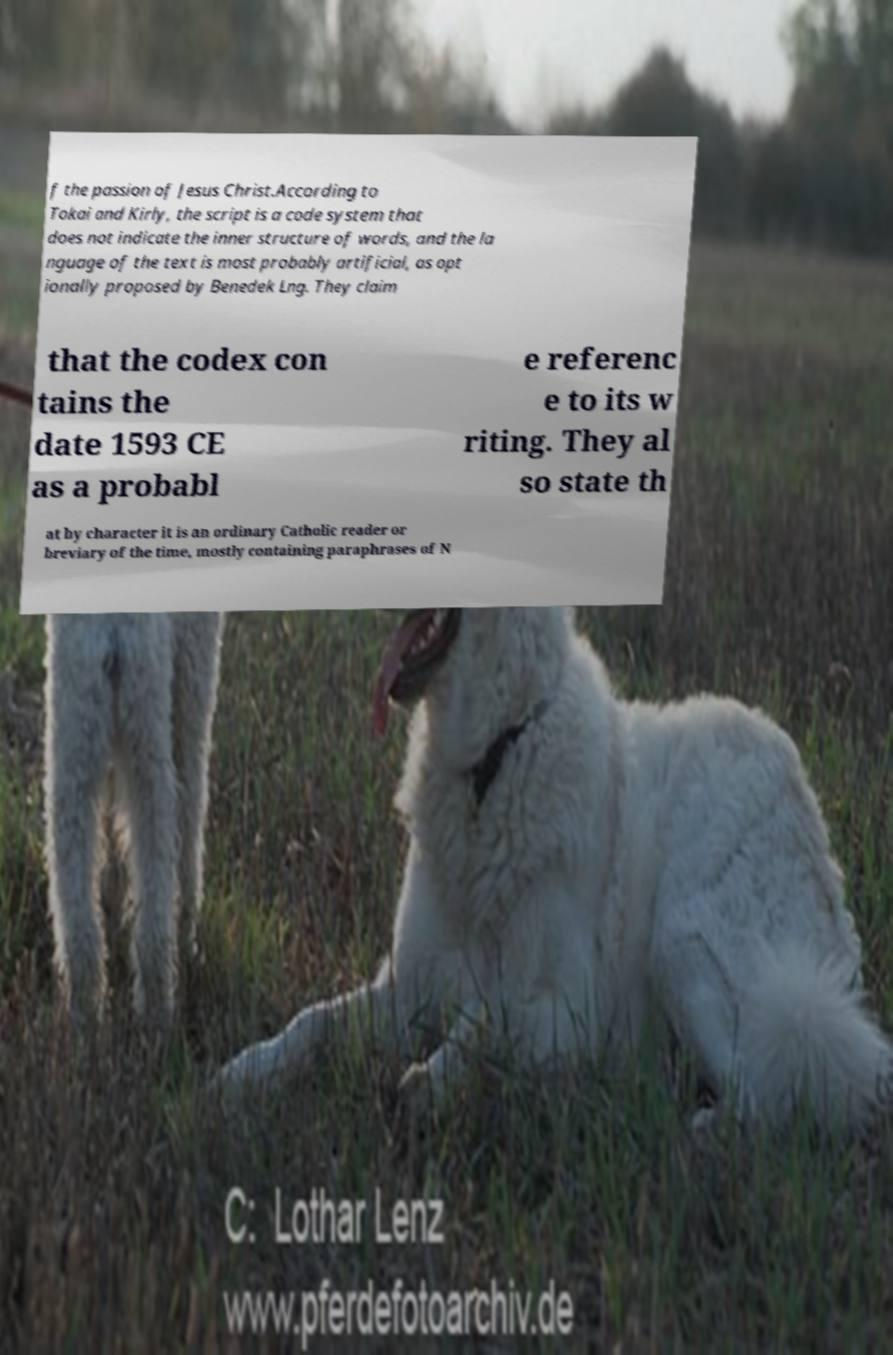Could you assist in decoding the text presented in this image and type it out clearly? f the passion of Jesus Christ.According to Tokai and Kirly, the script is a code system that does not indicate the inner structure of words, and the la nguage of the text is most probably artificial, as opt ionally proposed by Benedek Lng. They claim that the codex con tains the date 1593 CE as a probabl e referenc e to its w riting. They al so state th at by character it is an ordinary Catholic reader or breviary of the time, mostly containing paraphrases of N 